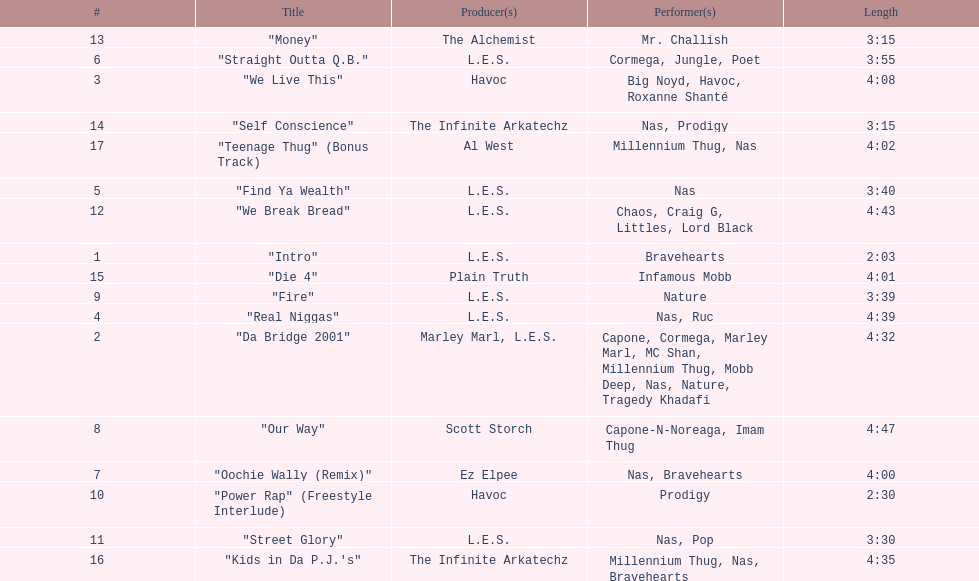What performers were in the last track? Millennium Thug, Nas. 